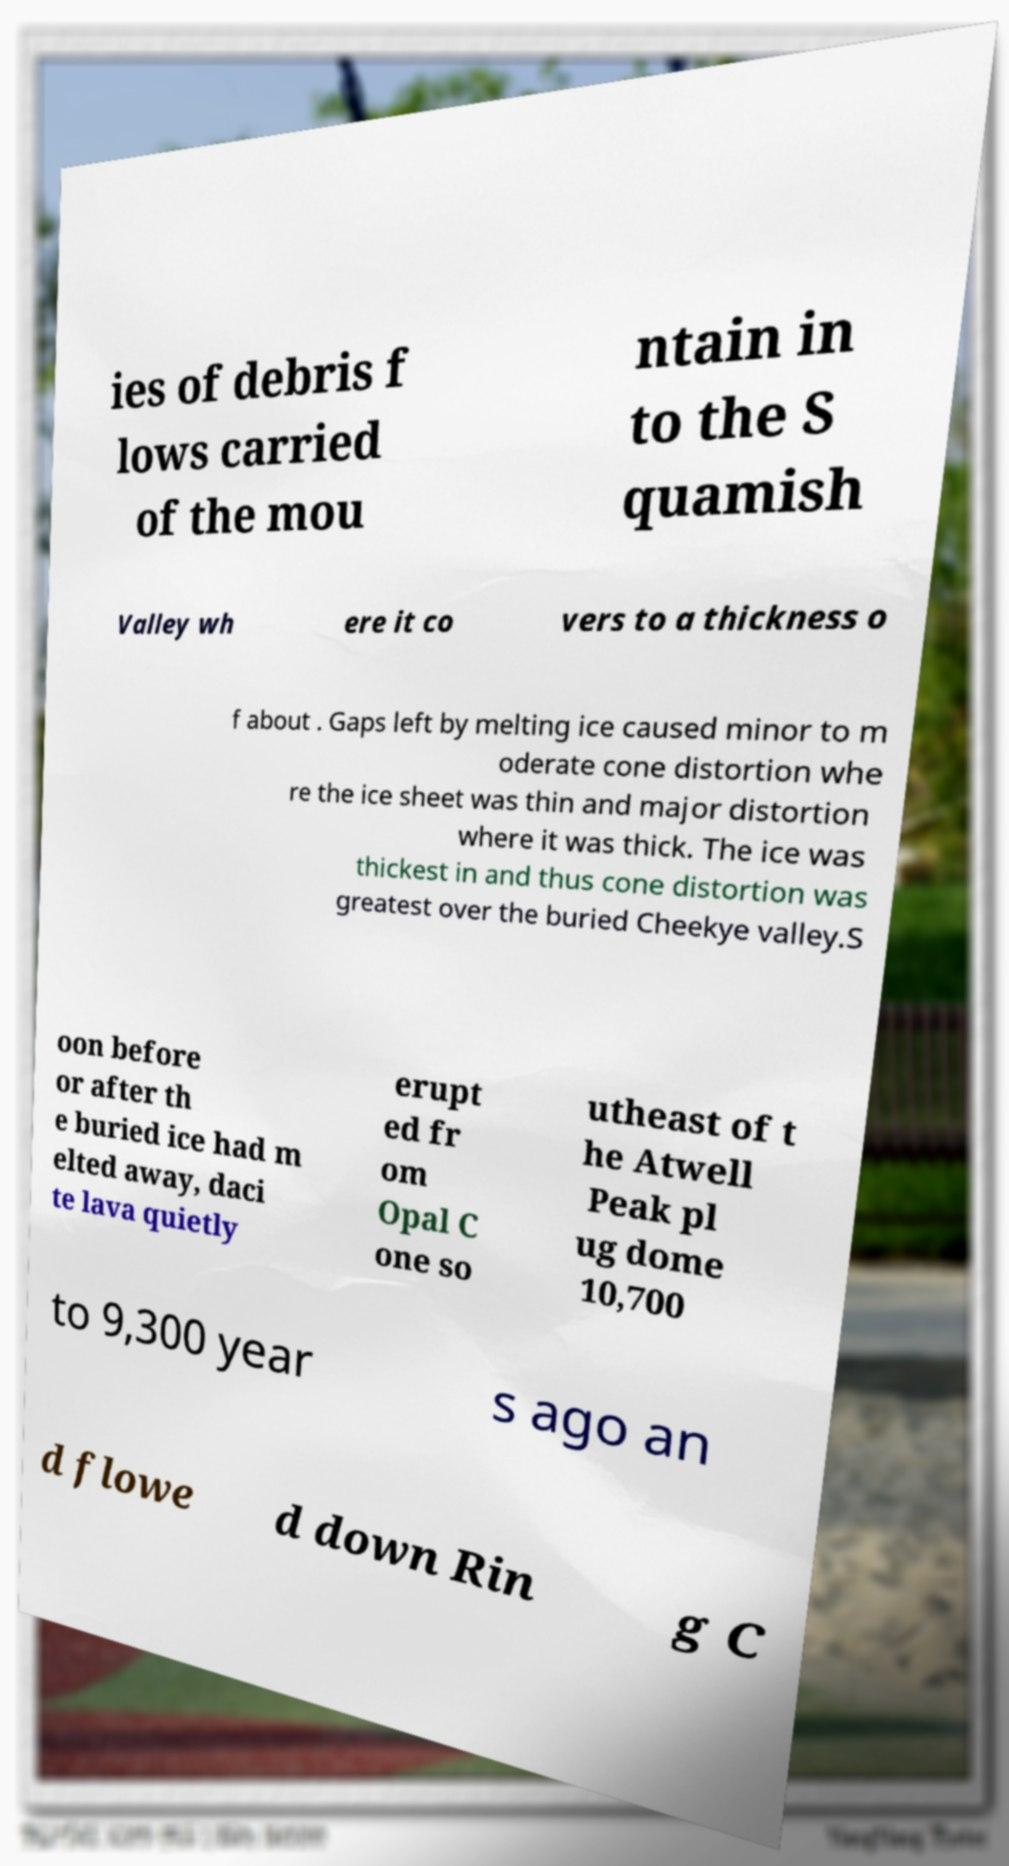Can you accurately transcribe the text from the provided image for me? ies of debris f lows carried of the mou ntain in to the S quamish Valley wh ere it co vers to a thickness o f about . Gaps left by melting ice caused minor to m oderate cone distortion whe re the ice sheet was thin and major distortion where it was thick. The ice was thickest in and thus cone distortion was greatest over the buried Cheekye valley.S oon before or after th e buried ice had m elted away, daci te lava quietly erupt ed fr om Opal C one so utheast of t he Atwell Peak pl ug dome 10,700 to 9,300 year s ago an d flowe d down Rin g C 